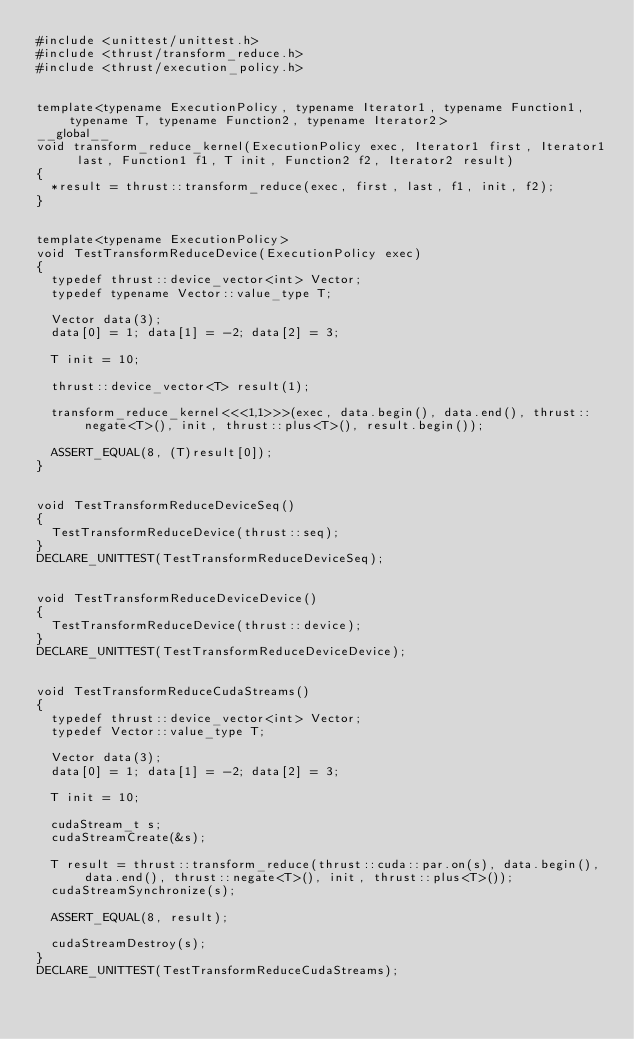<code> <loc_0><loc_0><loc_500><loc_500><_Cuda_>#include <unittest/unittest.h>
#include <thrust/transform_reduce.h>
#include <thrust/execution_policy.h>


template<typename ExecutionPolicy, typename Iterator1, typename Function1, typename T, typename Function2, typename Iterator2>
__global__
void transform_reduce_kernel(ExecutionPolicy exec, Iterator1 first, Iterator1 last, Function1 f1, T init, Function2 f2, Iterator2 result)
{
  *result = thrust::transform_reduce(exec, first, last, f1, init, f2);
}


template<typename ExecutionPolicy>
void TestTransformReduceDevice(ExecutionPolicy exec)
{
  typedef thrust::device_vector<int> Vector;
  typedef typename Vector::value_type T;
  
  Vector data(3);
  data[0] = 1; data[1] = -2; data[2] = 3;
  
  T init = 10;

  thrust::device_vector<T> result(1);

  transform_reduce_kernel<<<1,1>>>(exec, data.begin(), data.end(), thrust::negate<T>(), init, thrust::plus<T>(), result.begin());
  
  ASSERT_EQUAL(8, (T)result[0]);
}


void TestTransformReduceDeviceSeq()
{
  TestTransformReduceDevice(thrust::seq);
}
DECLARE_UNITTEST(TestTransformReduceDeviceSeq);


void TestTransformReduceDeviceDevice()
{
  TestTransformReduceDevice(thrust::device);
}
DECLARE_UNITTEST(TestTransformReduceDeviceDevice);


void TestTransformReduceCudaStreams()
{
  typedef thrust::device_vector<int> Vector;
  typedef Vector::value_type T;
  
  Vector data(3);
  data[0] = 1; data[1] = -2; data[2] = 3;
  
  T init = 10;

  cudaStream_t s;
  cudaStreamCreate(&s);

  T result = thrust::transform_reduce(thrust::cuda::par.on(s), data.begin(), data.end(), thrust::negate<T>(), init, thrust::plus<T>());
  cudaStreamSynchronize(s);
  
  ASSERT_EQUAL(8, result);

  cudaStreamDestroy(s);
}
DECLARE_UNITTEST(TestTransformReduceCudaStreams);

</code> 